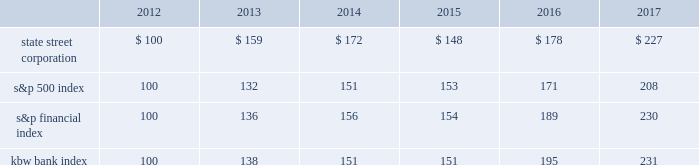State street corporation | 52 shareholder return performance presentation the graph presented below compares the cumulative total shareholder return on state street's common stock to the cumulative total return of the s&p 500 index , the s&p financial index and the kbw bank index over a five-year period .
The cumulative total shareholder return assumes the investment of $ 100 in state street common stock and in each index on december 31 , 2012 .
It also assumes reinvestment of common stock dividends .
The s&p financial index is a publicly available , capitalization-weighted index , comprised of 67 of the standard & poor 2019s 500 companies , representing 27 diversified financial services companies , 23 insurance companies , and 17 banking companies .
The kbw bank index is a modified cap-weighted index consisting of 24 exchange-listed stocks , representing national money center banks and leading regional institutions. .

What is the roi of an investment is state street corporation from 2012 to 2015? 
Computations: ((148 - 100) / 100)
Answer: 0.48. State street corporation | 52 shareholder return performance presentation the graph presented below compares the cumulative total shareholder return on state street's common stock to the cumulative total return of the s&p 500 index , the s&p financial index and the kbw bank index over a five-year period .
The cumulative total shareholder return assumes the investment of $ 100 in state street common stock and in each index on december 31 , 2012 .
It also assumes reinvestment of common stock dividends .
The s&p financial index is a publicly available , capitalization-weighted index , comprised of 67 of the standard & poor 2019s 500 companies , representing 27 diversified financial services companies , 23 insurance companies , and 17 banking companies .
The kbw bank index is a modified cap-weighted index consisting of 24 exchange-listed stocks , representing national money center banks and leading regional institutions. .

What percent returns did shareholders of state street corporation? 
Computations: ((227 - 100) / 100)
Answer: 1.27. 